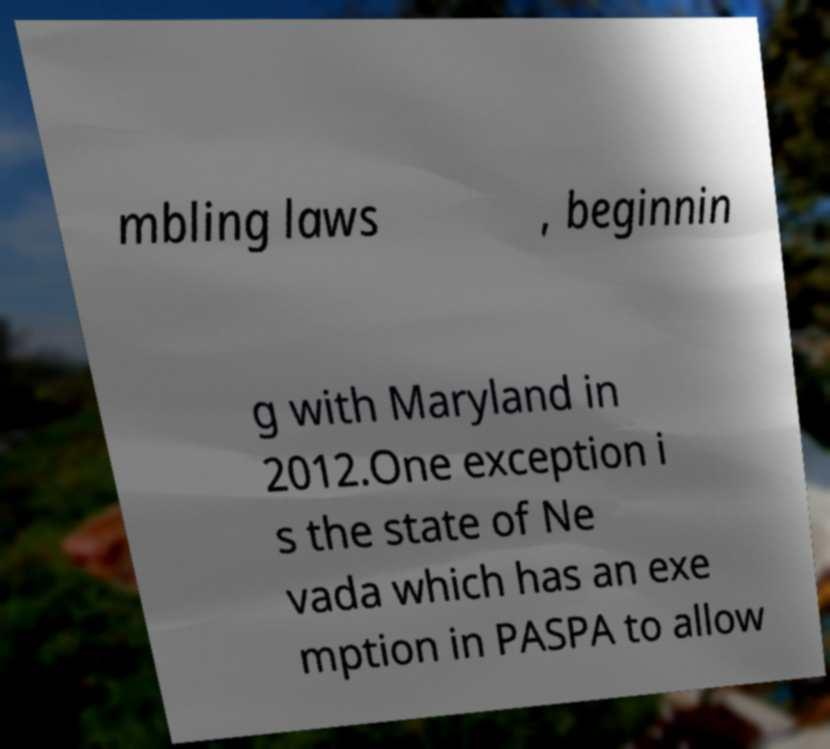Please identify and transcribe the text found in this image. mbling laws , beginnin g with Maryland in 2012.One exception i s the state of Ne vada which has an exe mption in PASPA to allow 